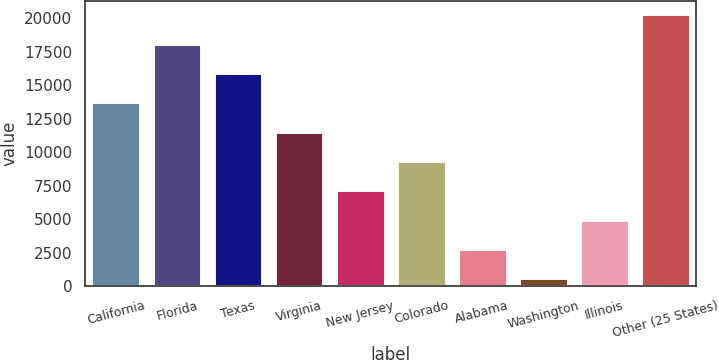<chart> <loc_0><loc_0><loc_500><loc_500><bar_chart><fcel>California<fcel>Florida<fcel>Texas<fcel>Virginia<fcel>New Jersey<fcel>Colorado<fcel>Alabama<fcel>Washington<fcel>Illinois<fcel>Other (25 States)<nl><fcel>13725.4<fcel>18110.2<fcel>15917.8<fcel>11533<fcel>7148.2<fcel>9340.6<fcel>2763.4<fcel>571<fcel>4955.8<fcel>20302.6<nl></chart> 